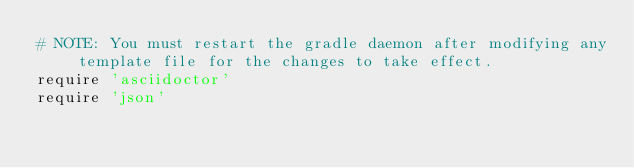<code> <loc_0><loc_0><loc_500><loc_500><_Ruby_># NOTE: You must restart the gradle daemon after modifying any template file for the changes to take effect.
require 'asciidoctor'
require 'json'
</code> 